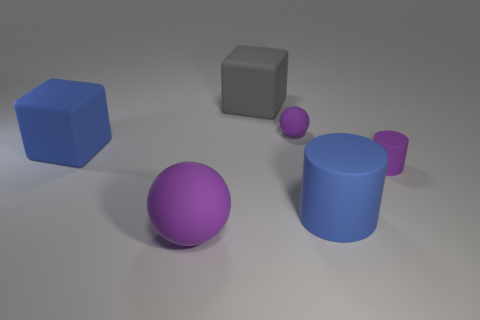Add 1 tiny brown balls. How many objects exist? 7 Subtract all balls. How many objects are left? 4 Subtract all tiny purple balls. Subtract all small spheres. How many objects are left? 4 Add 1 purple cylinders. How many purple cylinders are left? 2 Add 4 blue metal objects. How many blue metal objects exist? 4 Subtract 0 gray cylinders. How many objects are left? 6 